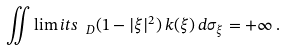<formula> <loc_0><loc_0><loc_500><loc_500>\iint \lim i t s _ { \ D } ( 1 - | \xi | ^ { 2 } ) \, k ( \xi ) \, d \sigma _ { \xi } = + \infty \, .</formula> 